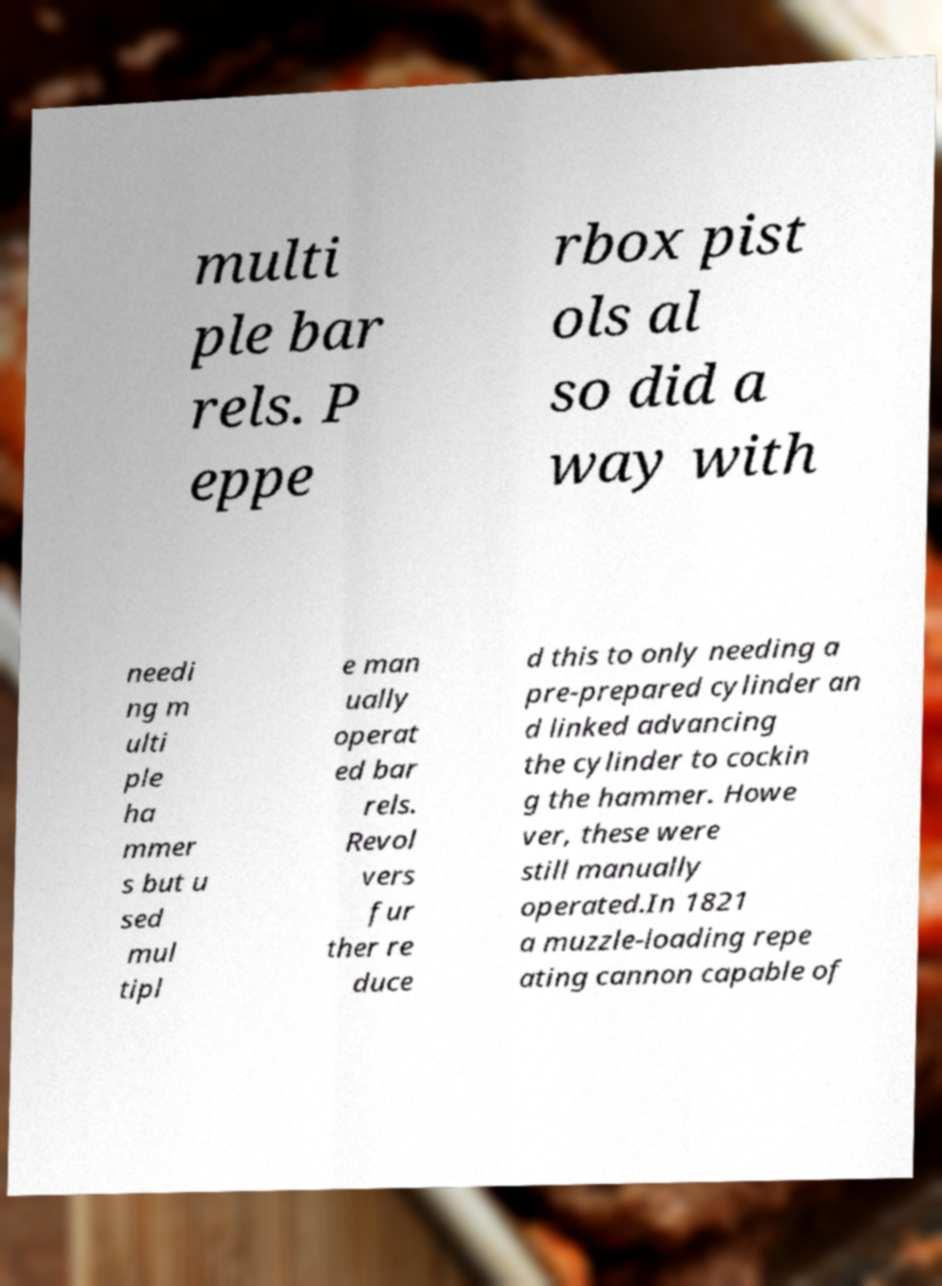Can you accurately transcribe the text from the provided image for me? multi ple bar rels. P eppe rbox pist ols al so did a way with needi ng m ulti ple ha mmer s but u sed mul tipl e man ually operat ed bar rels. Revol vers fur ther re duce d this to only needing a pre-prepared cylinder an d linked advancing the cylinder to cockin g the hammer. Howe ver, these were still manually operated.In 1821 a muzzle-loading repe ating cannon capable of 